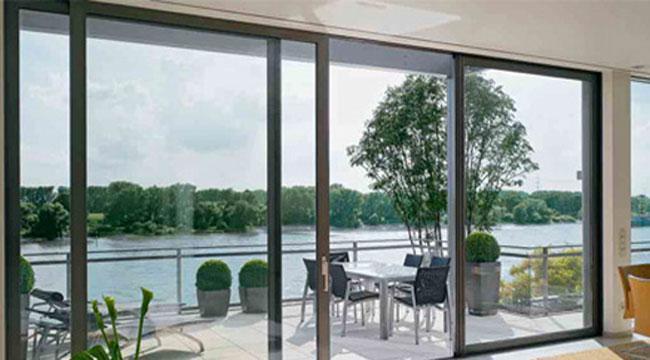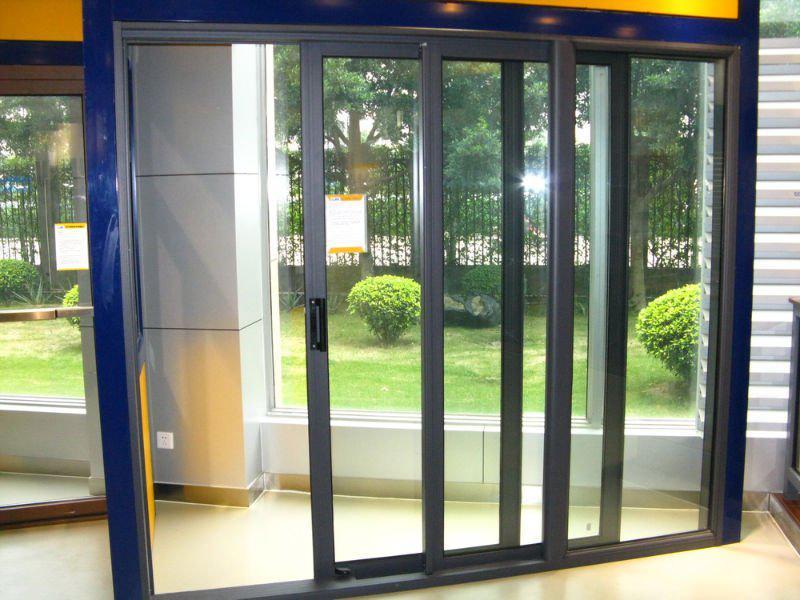The first image is the image on the left, the second image is the image on the right. Assess this claim about the two images: "The doors in the image on the right open to a grassy area.". Correct or not? Answer yes or no. Yes. The first image is the image on the left, the second image is the image on the right. For the images displayed, is the sentence "An image shows a sliding door unit providing an unobstructed view that is at least as wide as it is tall." factually correct? Answer yes or no. No. 